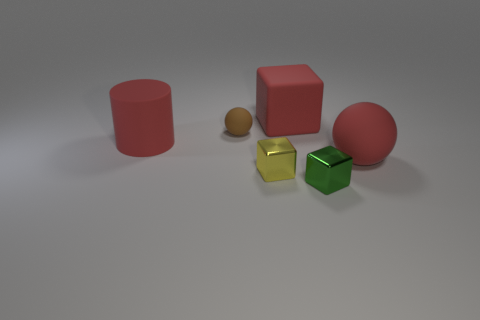There is a metal cube on the right side of the red cube; is it the same size as the large red ball?
Keep it short and to the point. No. Is the color of the rubber block the same as the cylinder?
Make the answer very short. Yes. What number of tiny brown objects have the same shape as the tiny green metallic thing?
Make the answer very short. 0. Are the red block and the red ball made of the same material?
Ensure brevity in your answer.  Yes. What is the shape of the small metal object that is behind the tiny green thing that is in front of the yellow metal object?
Your response must be concise. Cube. There is a large red object that is left of the tiny rubber thing; how many big rubber cylinders are on the left side of it?
Provide a short and direct response. 0. There is a block that is behind the green metallic thing and in front of the big cylinder; what material is it?
Provide a short and direct response. Metal. There is another matte thing that is the same size as the green thing; what shape is it?
Offer a very short reply. Sphere. There is a small block in front of the metal thing to the left of the big red rubber thing behind the small ball; what color is it?
Ensure brevity in your answer.  Green. What number of things are either rubber balls left of the red sphere or tiny rubber objects?
Offer a very short reply. 1. 